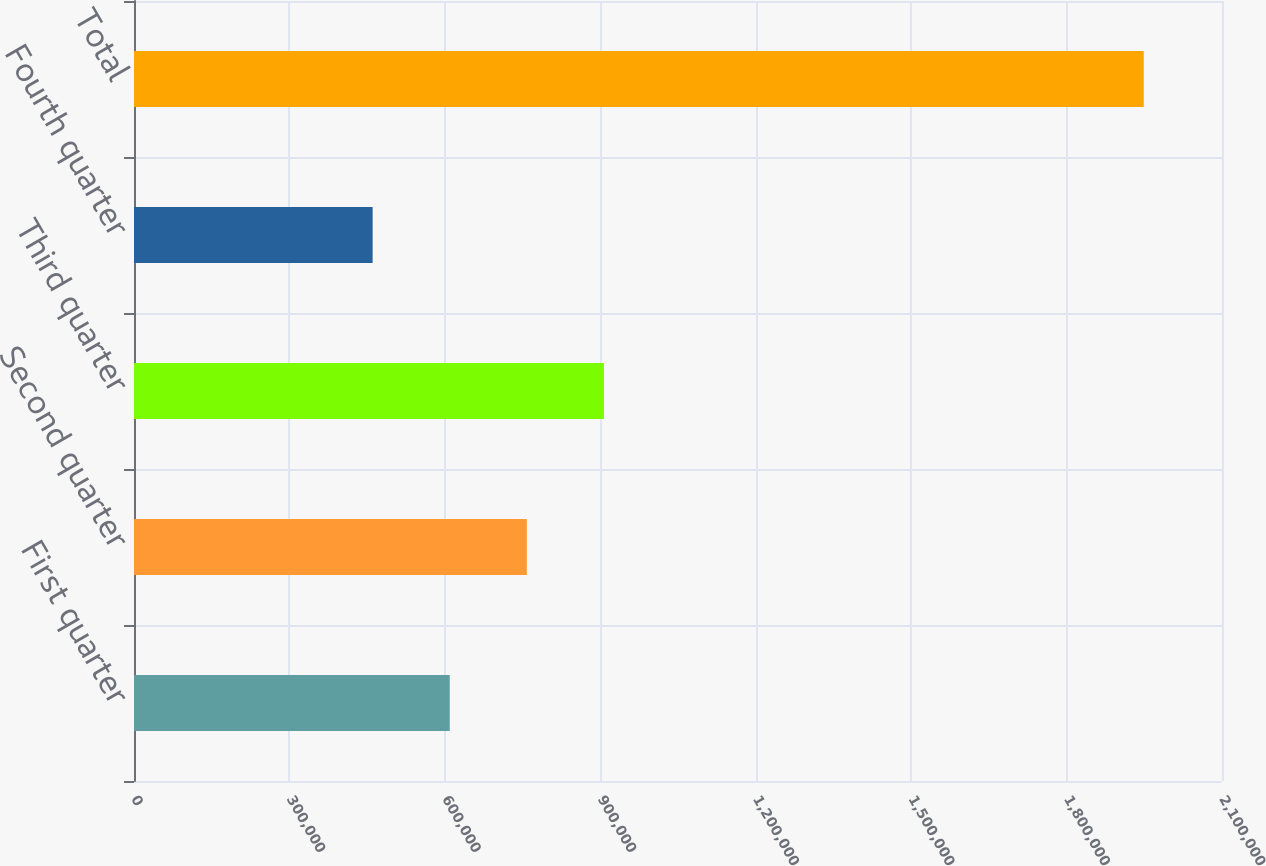Convert chart to OTSL. <chart><loc_0><loc_0><loc_500><loc_500><bar_chart><fcel>First quarter<fcel>Second quarter<fcel>Third quarter<fcel>Fourth quarter<fcel>Total<nl><fcel>609408<fcel>758244<fcel>907081<fcel>460572<fcel>1.94893e+06<nl></chart> 